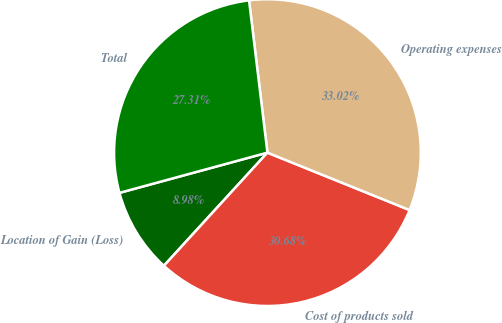<chart> <loc_0><loc_0><loc_500><loc_500><pie_chart><fcel>Location of Gain (Loss)<fcel>Cost of products sold<fcel>Operating expenses<fcel>Total<nl><fcel>8.98%<fcel>30.68%<fcel>33.02%<fcel>27.31%<nl></chart> 